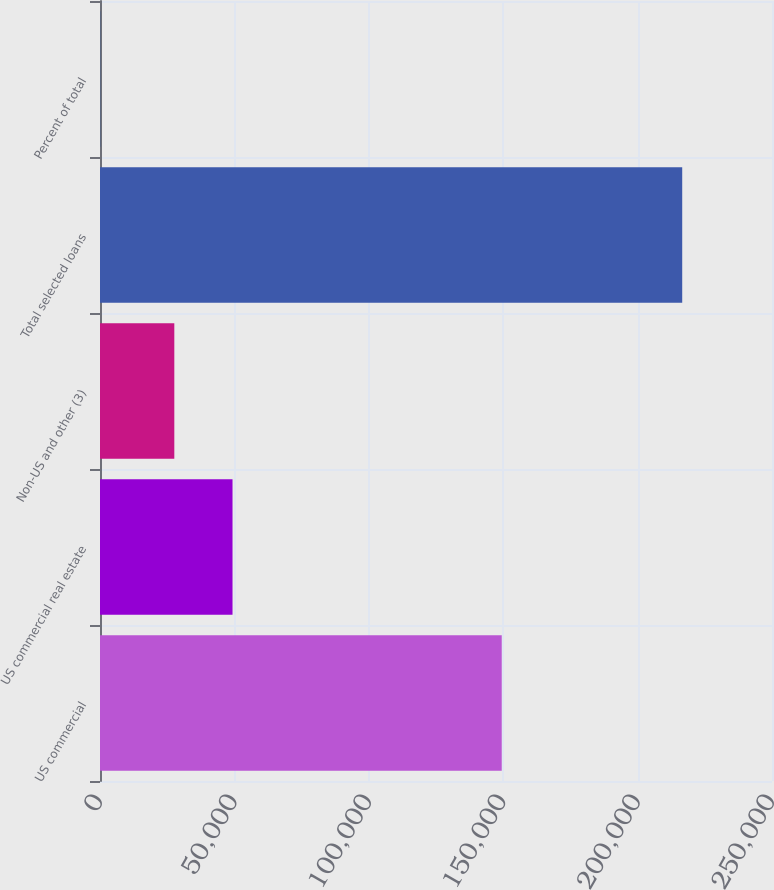<chart> <loc_0><loc_0><loc_500><loc_500><bar_chart><fcel>US commercial<fcel>US commercial real estate<fcel>Non-US and other (3)<fcel>Total selected loans<fcel>Percent of total<nl><fcel>149456<fcel>49300.6<fcel>27646<fcel>216597<fcel>51<nl></chart> 